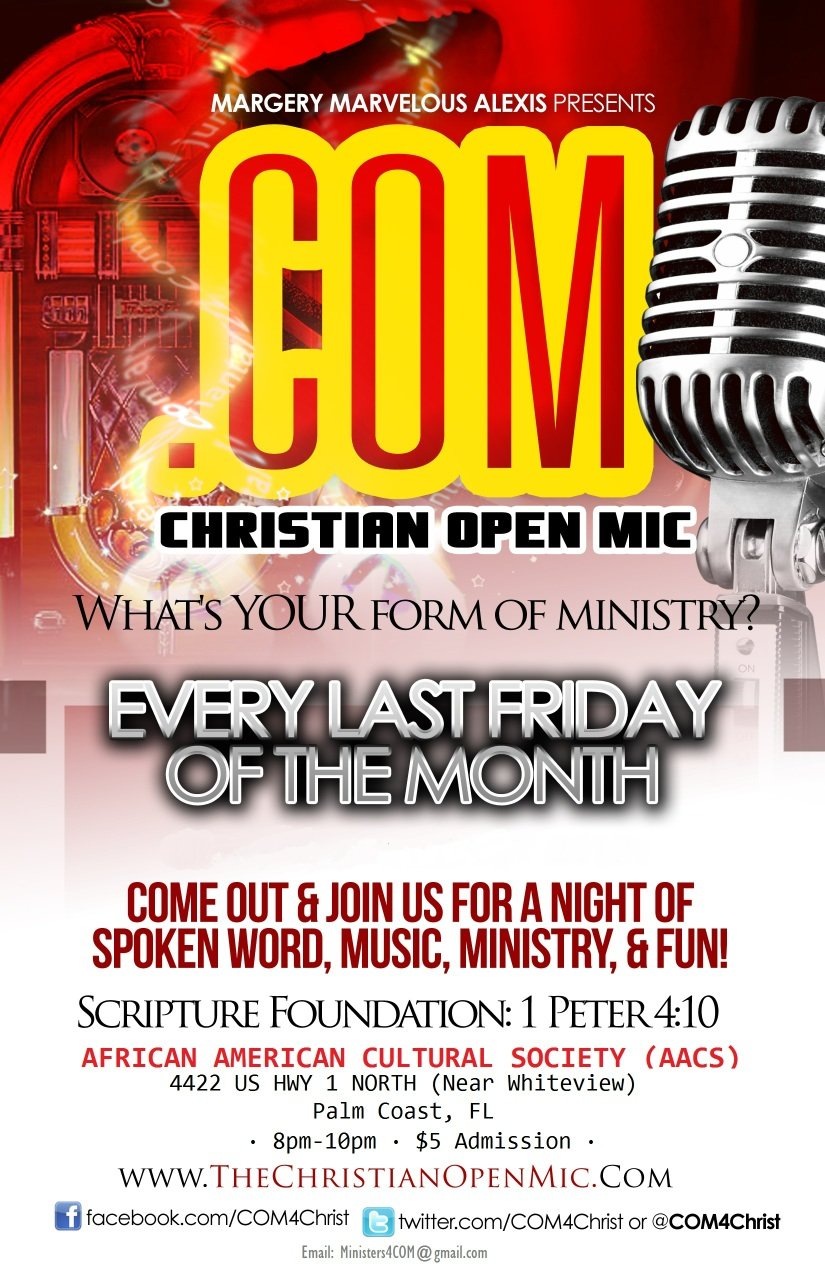What does this say? The image is an advertisement for 'Christian Open Mic', an event hosted by Margery Marvelous Alexis. It takes place every last Friday of the month at the African American Cultural Society in Palm Coast, FL. The event features spoken word, music, ministry, and fun, from 8 pm to 10 pm with a $5 admission fee. The scripture foundation mentioned is 1 Peter 4:10. More information can be found at their website www.TheChristianOpenMic.com, and they are also active on Facebook and Twitter. 